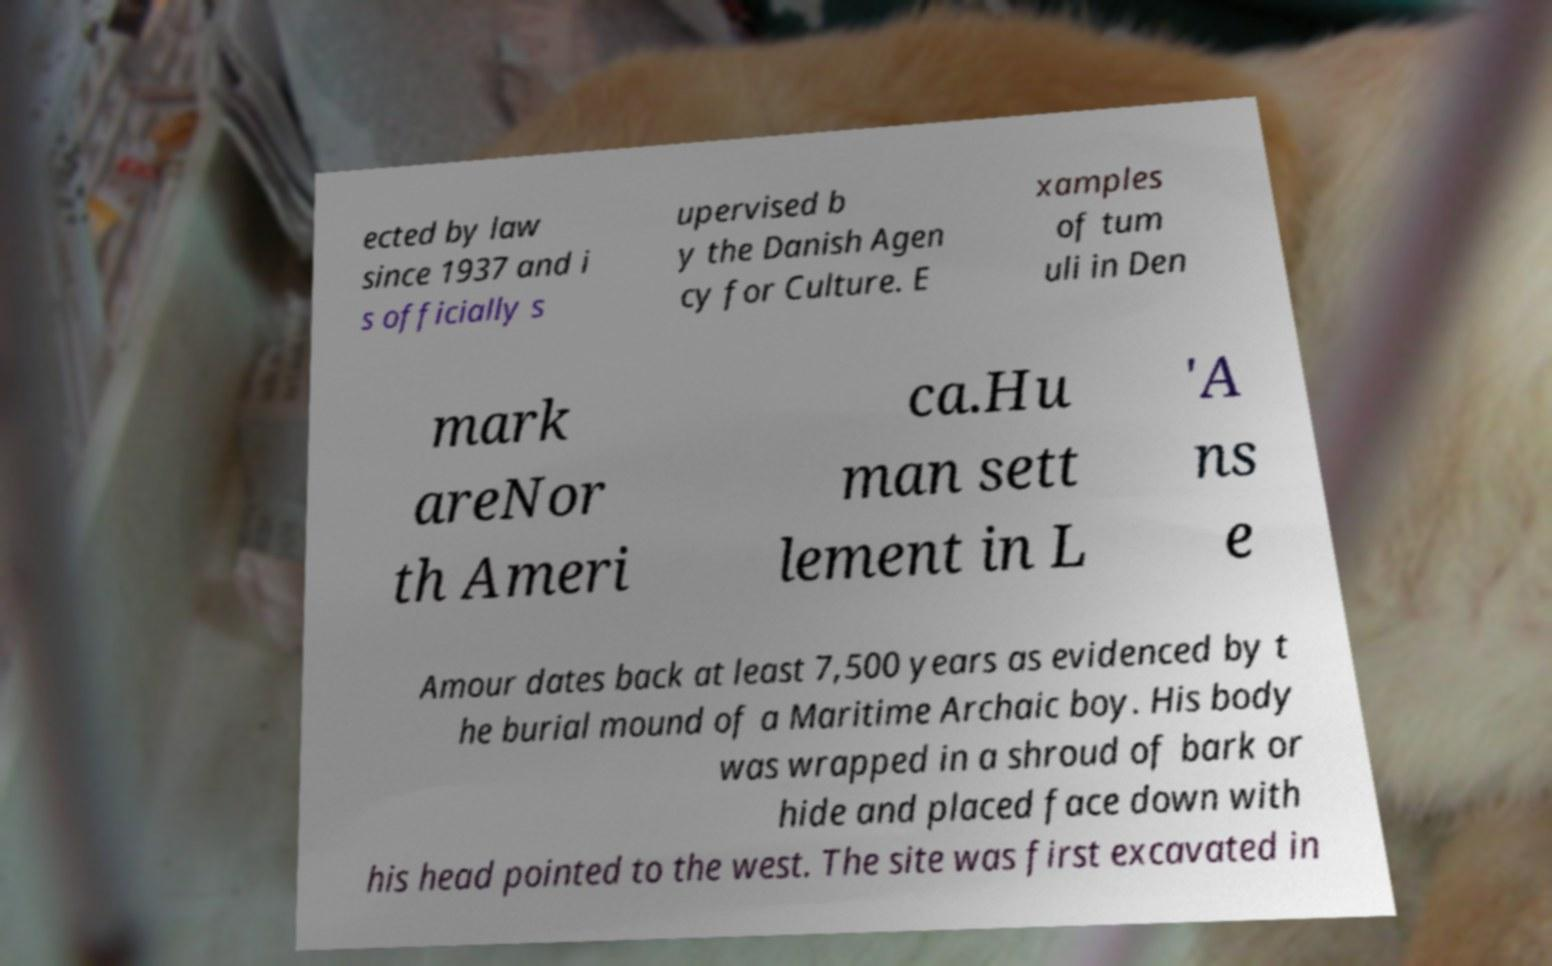Can you read and provide the text displayed in the image?This photo seems to have some interesting text. Can you extract and type it out for me? ected by law since 1937 and i s officially s upervised b y the Danish Agen cy for Culture. E xamples of tum uli in Den mark areNor th Ameri ca.Hu man sett lement in L 'A ns e Amour dates back at least 7,500 years as evidenced by t he burial mound of a Maritime Archaic boy. His body was wrapped in a shroud of bark or hide and placed face down with his head pointed to the west. The site was first excavated in 